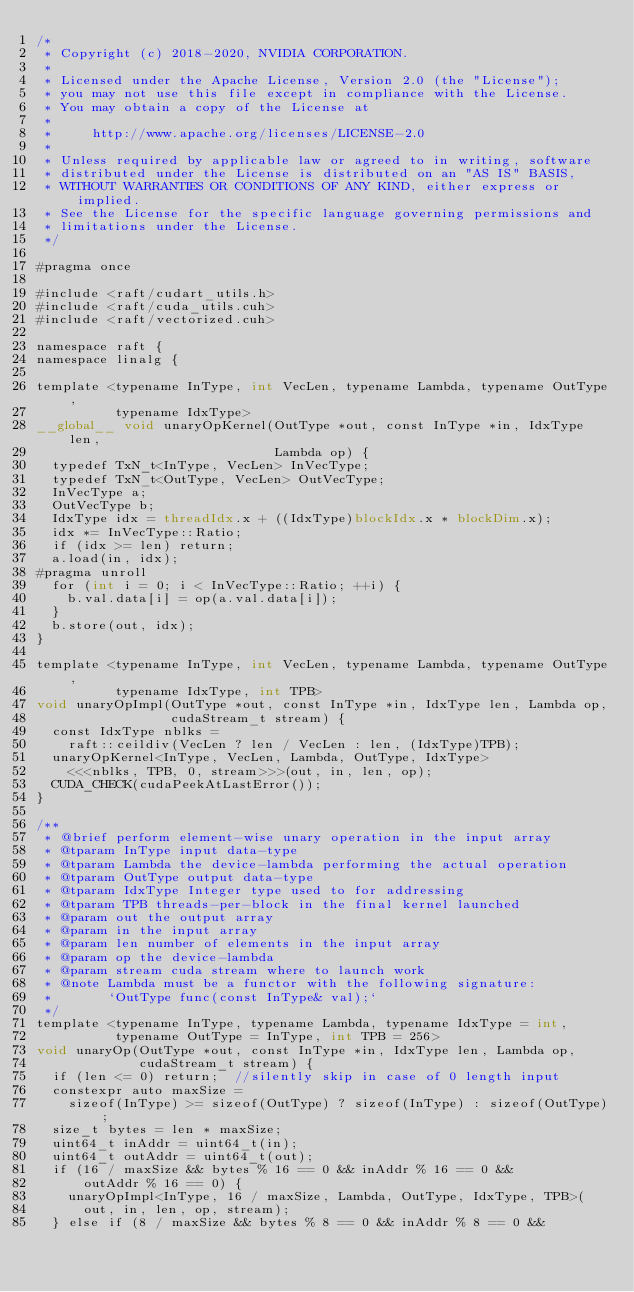Convert code to text. <code><loc_0><loc_0><loc_500><loc_500><_Cuda_>/*
 * Copyright (c) 2018-2020, NVIDIA CORPORATION.
 *
 * Licensed under the Apache License, Version 2.0 (the "License");
 * you may not use this file except in compliance with the License.
 * You may obtain a copy of the License at
 *
 *     http://www.apache.org/licenses/LICENSE-2.0
 *
 * Unless required by applicable law or agreed to in writing, software
 * distributed under the License is distributed on an "AS IS" BASIS,
 * WITHOUT WARRANTIES OR CONDITIONS OF ANY KIND, either express or implied.
 * See the License for the specific language governing permissions and
 * limitations under the License.
 */

#pragma once

#include <raft/cudart_utils.h>
#include <raft/cuda_utils.cuh>
#include <raft/vectorized.cuh>

namespace raft {
namespace linalg {

template <typename InType, int VecLen, typename Lambda, typename OutType,
          typename IdxType>
__global__ void unaryOpKernel(OutType *out, const InType *in, IdxType len,
                              Lambda op) {
  typedef TxN_t<InType, VecLen> InVecType;
  typedef TxN_t<OutType, VecLen> OutVecType;
  InVecType a;
  OutVecType b;
  IdxType idx = threadIdx.x + ((IdxType)blockIdx.x * blockDim.x);
  idx *= InVecType::Ratio;
  if (idx >= len) return;
  a.load(in, idx);
#pragma unroll
  for (int i = 0; i < InVecType::Ratio; ++i) {
    b.val.data[i] = op(a.val.data[i]);
  }
  b.store(out, idx);
}

template <typename InType, int VecLen, typename Lambda, typename OutType,
          typename IdxType, int TPB>
void unaryOpImpl(OutType *out, const InType *in, IdxType len, Lambda op,
                 cudaStream_t stream) {
  const IdxType nblks =
    raft::ceildiv(VecLen ? len / VecLen : len, (IdxType)TPB);
  unaryOpKernel<InType, VecLen, Lambda, OutType, IdxType>
    <<<nblks, TPB, 0, stream>>>(out, in, len, op);
  CUDA_CHECK(cudaPeekAtLastError());
}

/**
 * @brief perform element-wise unary operation in the input array
 * @tparam InType input data-type
 * @tparam Lambda the device-lambda performing the actual operation
 * @tparam OutType output data-type
 * @tparam IdxType Integer type used to for addressing
 * @tparam TPB threads-per-block in the final kernel launched
 * @param out the output array
 * @param in the input array
 * @param len number of elements in the input array
 * @param op the device-lambda
 * @param stream cuda stream where to launch work
 * @note Lambda must be a functor with the following signature:
 *       `OutType func(const InType& val);`
 */
template <typename InType, typename Lambda, typename IdxType = int,
          typename OutType = InType, int TPB = 256>
void unaryOp(OutType *out, const InType *in, IdxType len, Lambda op,
             cudaStream_t stream) {
  if (len <= 0) return;  //silently skip in case of 0 length input
  constexpr auto maxSize =
    sizeof(InType) >= sizeof(OutType) ? sizeof(InType) : sizeof(OutType);
  size_t bytes = len * maxSize;
  uint64_t inAddr = uint64_t(in);
  uint64_t outAddr = uint64_t(out);
  if (16 / maxSize && bytes % 16 == 0 && inAddr % 16 == 0 &&
      outAddr % 16 == 0) {
    unaryOpImpl<InType, 16 / maxSize, Lambda, OutType, IdxType, TPB>(
      out, in, len, op, stream);
  } else if (8 / maxSize && bytes % 8 == 0 && inAddr % 8 == 0 &&</code> 